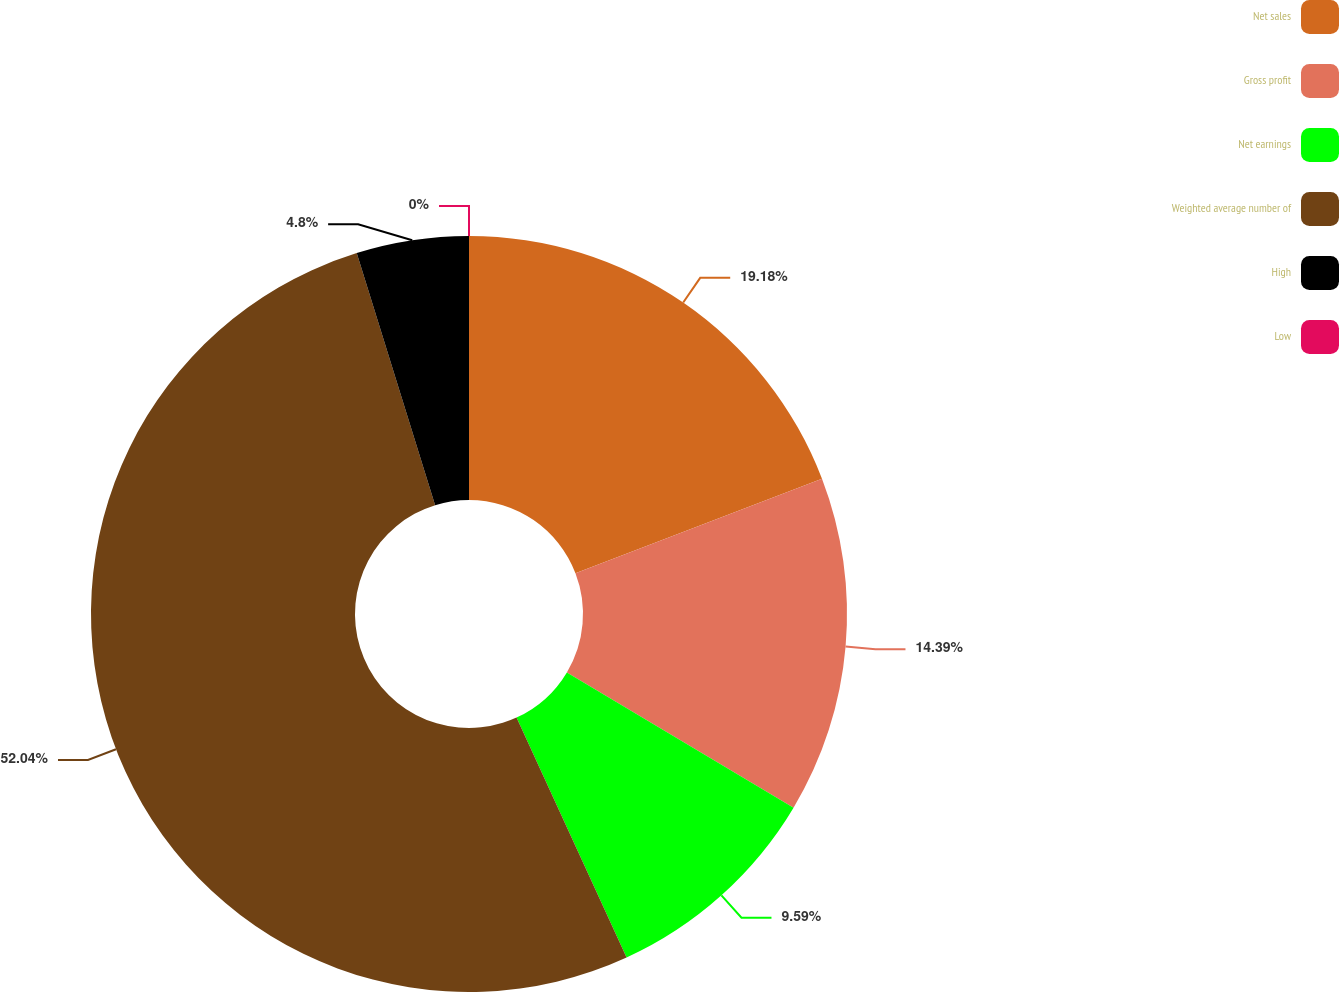<chart> <loc_0><loc_0><loc_500><loc_500><pie_chart><fcel>Net sales<fcel>Gross profit<fcel>Net earnings<fcel>Weighted average number of<fcel>High<fcel>Low<nl><fcel>19.18%<fcel>14.39%<fcel>9.59%<fcel>52.05%<fcel>4.8%<fcel>0.0%<nl></chart> 